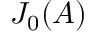<formula> <loc_0><loc_0><loc_500><loc_500>J _ { 0 } ( A )</formula> 